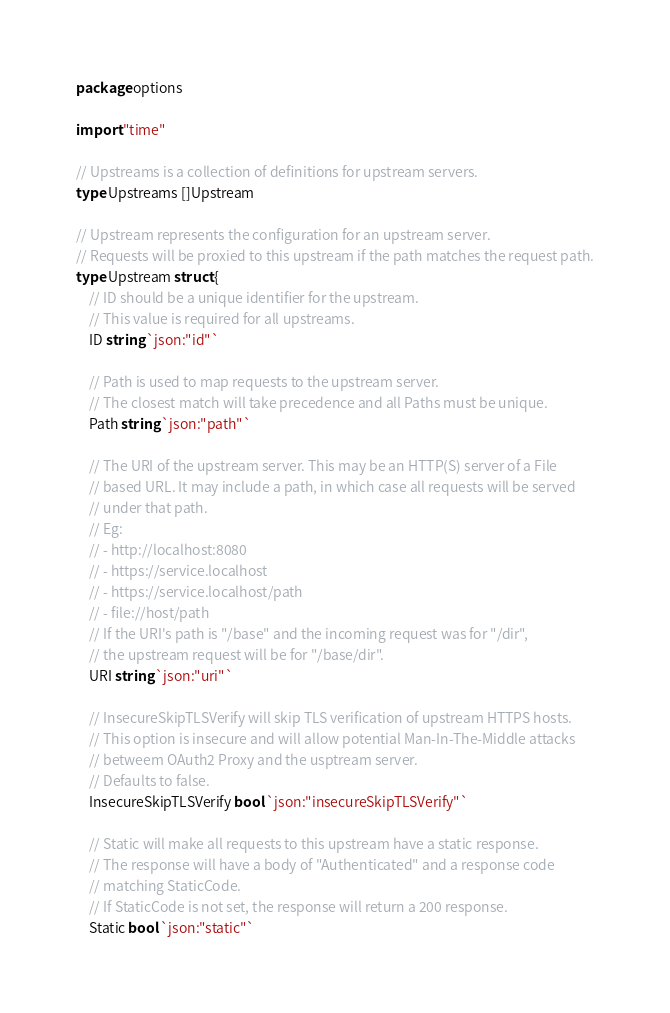Convert code to text. <code><loc_0><loc_0><loc_500><loc_500><_Go_>package options

import "time"

// Upstreams is a collection of definitions for upstream servers.
type Upstreams []Upstream

// Upstream represents the configuration for an upstream server.
// Requests will be proxied to this upstream if the path matches the request path.
type Upstream struct {
	// ID should be a unique identifier for the upstream.
	// This value is required for all upstreams.
	ID string `json:"id"`

	// Path is used to map requests to the upstream server.
	// The closest match will take precedence and all Paths must be unique.
	Path string `json:"path"`

	// The URI of the upstream server. This may be an HTTP(S) server of a File
	// based URL. It may include a path, in which case all requests will be served
	// under that path.
	// Eg:
	// - http://localhost:8080
	// - https://service.localhost
	// - https://service.localhost/path
	// - file://host/path
	// If the URI's path is "/base" and the incoming request was for "/dir",
	// the upstream request will be for "/base/dir".
	URI string `json:"uri"`

	// InsecureSkipTLSVerify will skip TLS verification of upstream HTTPS hosts.
	// This option is insecure and will allow potential Man-In-The-Middle attacks
	// betweem OAuth2 Proxy and the usptream server.
	// Defaults to false.
	InsecureSkipTLSVerify bool `json:"insecureSkipTLSVerify"`

	// Static will make all requests to this upstream have a static response.
	// The response will have a body of "Authenticated" and a response code
	// matching StaticCode.
	// If StaticCode is not set, the response will return a 200 response.
	Static bool `json:"static"`
</code> 